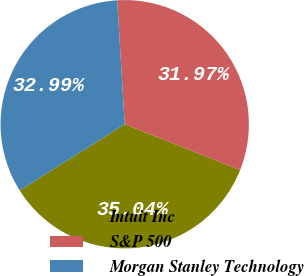Convert chart. <chart><loc_0><loc_0><loc_500><loc_500><pie_chart><fcel>Intuit Inc<fcel>S&P 500<fcel>Morgan Stanley Technology<nl><fcel>35.04%<fcel>31.97%<fcel>32.99%<nl></chart> 